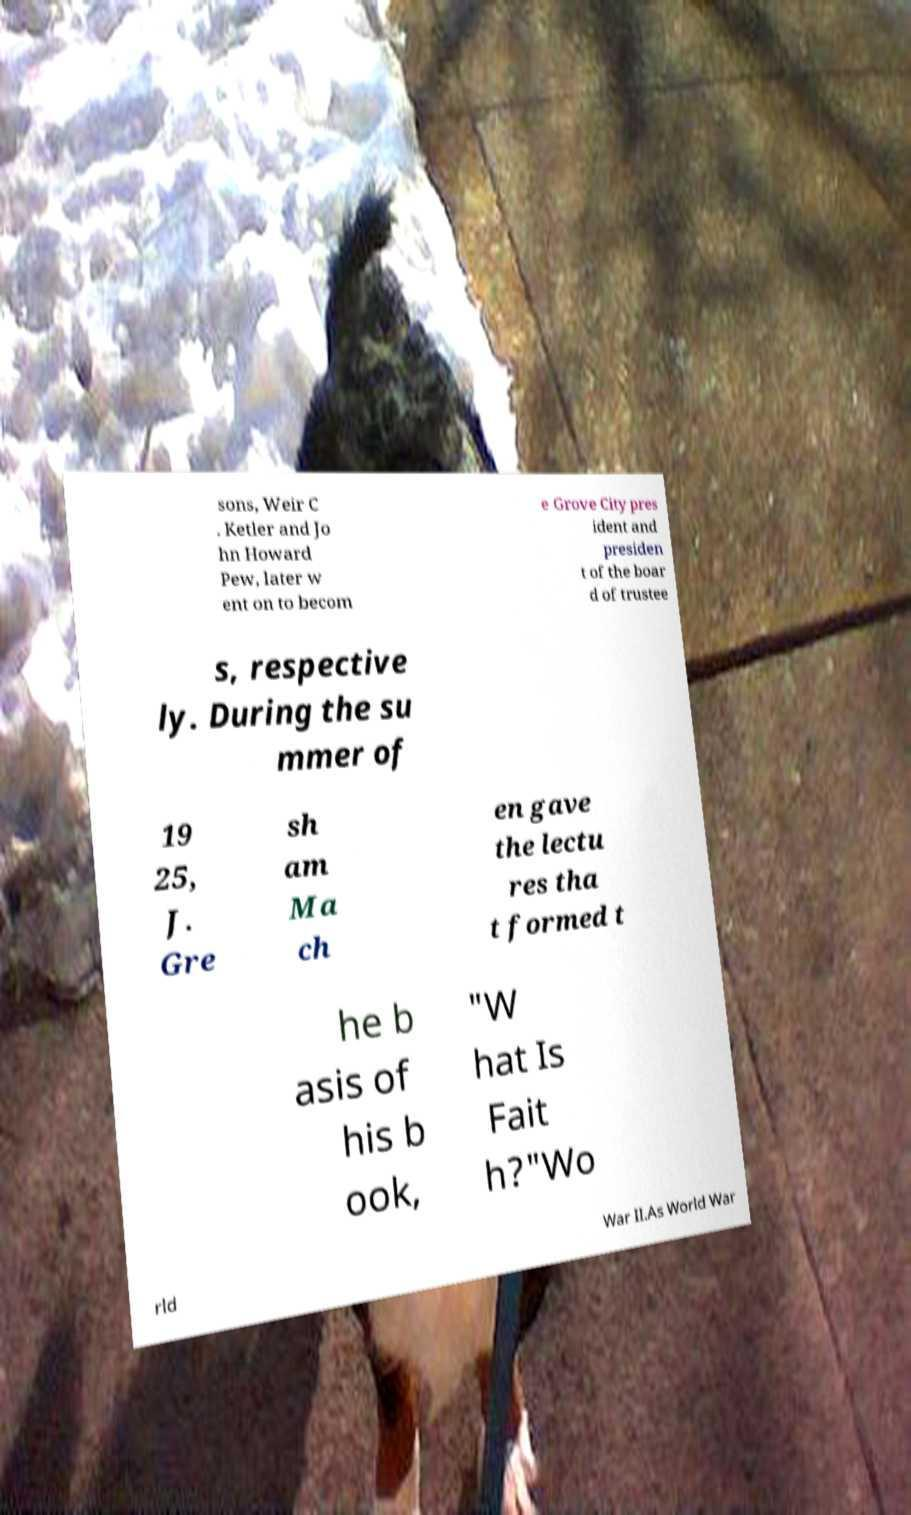Please read and relay the text visible in this image. What does it say? sons, Weir C . Ketler and Jo hn Howard Pew, later w ent on to becom e Grove City pres ident and presiden t of the boar d of trustee s, respective ly. During the su mmer of 19 25, J. Gre sh am Ma ch en gave the lectu res tha t formed t he b asis of his b ook, "W hat Is Fait h?"Wo rld War II.As World War 